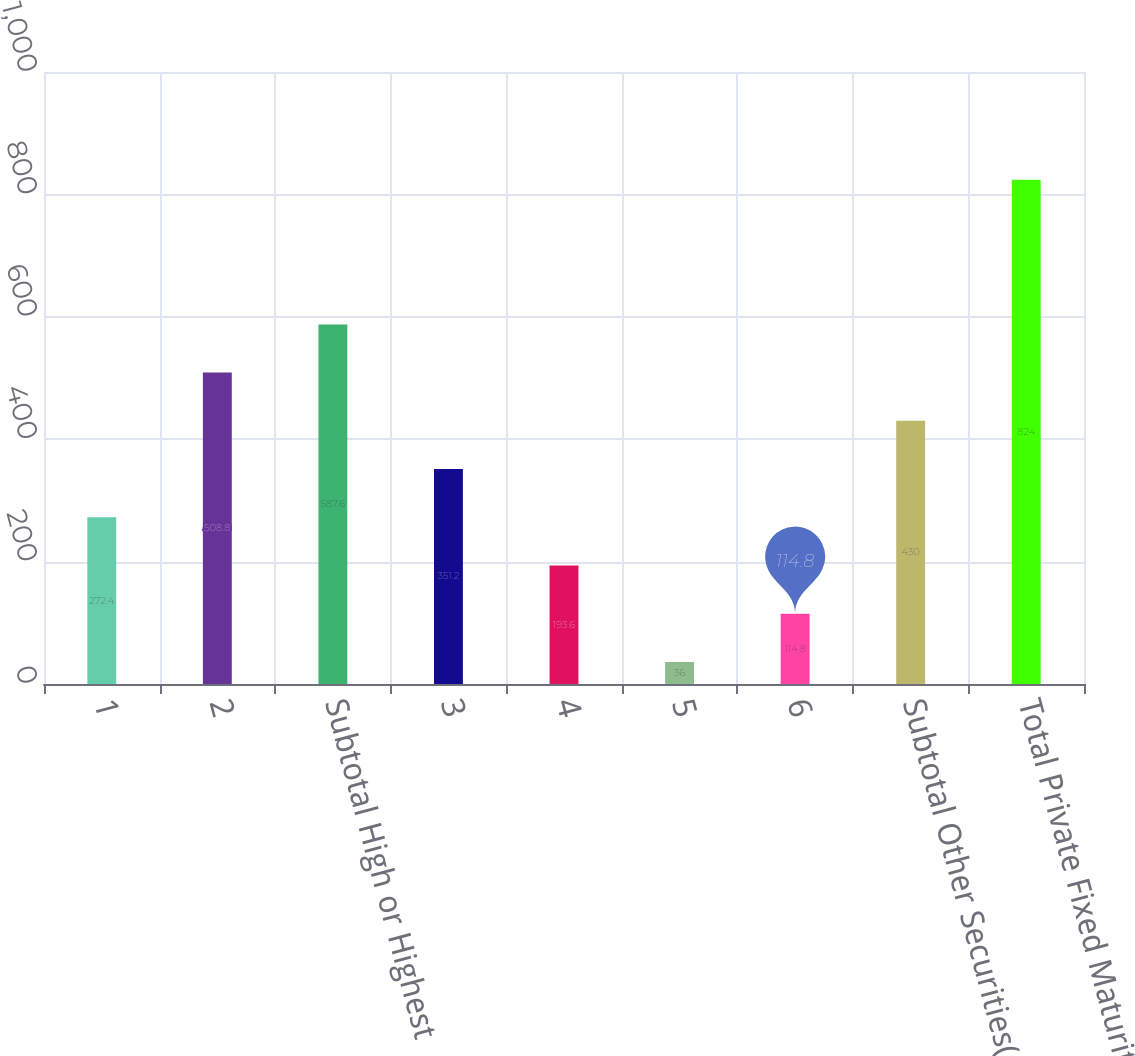Convert chart to OTSL. <chart><loc_0><loc_0><loc_500><loc_500><bar_chart><fcel>1<fcel>2<fcel>Subtotal High or Highest<fcel>3<fcel>4<fcel>5<fcel>6<fcel>Subtotal Other Securities(4)<fcel>Total Private Fixed Maturities<nl><fcel>272.4<fcel>508.8<fcel>587.6<fcel>351.2<fcel>193.6<fcel>36<fcel>114.8<fcel>430<fcel>824<nl></chart> 